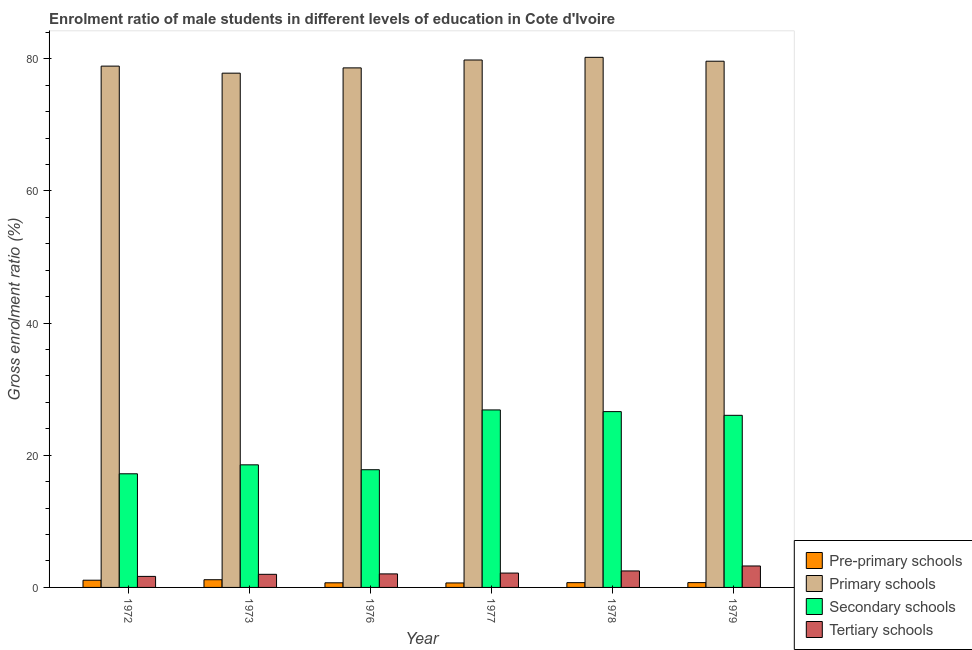How many different coloured bars are there?
Make the answer very short. 4. Are the number of bars per tick equal to the number of legend labels?
Make the answer very short. Yes. How many bars are there on the 6th tick from the left?
Provide a succinct answer. 4. What is the gross enrolment ratio(female) in pre-primary schools in 1976?
Keep it short and to the point. 0.7. Across all years, what is the maximum gross enrolment ratio(female) in tertiary schools?
Offer a very short reply. 3.25. Across all years, what is the minimum gross enrolment ratio(female) in primary schools?
Your response must be concise. 77.82. In which year was the gross enrolment ratio(female) in primary schools maximum?
Your answer should be compact. 1978. In which year was the gross enrolment ratio(female) in secondary schools minimum?
Your response must be concise. 1972. What is the total gross enrolment ratio(female) in secondary schools in the graph?
Offer a very short reply. 133.07. What is the difference between the gross enrolment ratio(female) in pre-primary schools in 1972 and that in 1978?
Give a very brief answer. 0.37. What is the difference between the gross enrolment ratio(female) in secondary schools in 1976 and the gross enrolment ratio(female) in primary schools in 1977?
Offer a terse response. -9.05. What is the average gross enrolment ratio(female) in pre-primary schools per year?
Give a very brief answer. 0.85. In the year 1977, what is the difference between the gross enrolment ratio(female) in tertiary schools and gross enrolment ratio(female) in secondary schools?
Offer a terse response. 0. In how many years, is the gross enrolment ratio(female) in primary schools greater than 28 %?
Provide a succinct answer. 6. What is the ratio of the gross enrolment ratio(female) in primary schools in 1976 to that in 1979?
Provide a succinct answer. 0.99. Is the gross enrolment ratio(female) in primary schools in 1972 less than that in 1977?
Provide a succinct answer. Yes. Is the difference between the gross enrolment ratio(female) in pre-primary schools in 1972 and 1979 greater than the difference between the gross enrolment ratio(female) in secondary schools in 1972 and 1979?
Provide a succinct answer. No. What is the difference between the highest and the second highest gross enrolment ratio(female) in primary schools?
Offer a very short reply. 0.4. What is the difference between the highest and the lowest gross enrolment ratio(female) in pre-primary schools?
Make the answer very short. 0.49. In how many years, is the gross enrolment ratio(female) in pre-primary schools greater than the average gross enrolment ratio(female) in pre-primary schools taken over all years?
Provide a short and direct response. 2. Is the sum of the gross enrolment ratio(female) in secondary schools in 1978 and 1979 greater than the maximum gross enrolment ratio(female) in primary schools across all years?
Make the answer very short. Yes. Is it the case that in every year, the sum of the gross enrolment ratio(female) in primary schools and gross enrolment ratio(female) in secondary schools is greater than the sum of gross enrolment ratio(female) in pre-primary schools and gross enrolment ratio(female) in tertiary schools?
Your response must be concise. Yes. What does the 1st bar from the left in 1972 represents?
Your response must be concise. Pre-primary schools. What does the 4th bar from the right in 1977 represents?
Offer a very short reply. Pre-primary schools. Is it the case that in every year, the sum of the gross enrolment ratio(female) in pre-primary schools and gross enrolment ratio(female) in primary schools is greater than the gross enrolment ratio(female) in secondary schools?
Offer a very short reply. Yes. How many bars are there?
Your answer should be compact. 24. Are all the bars in the graph horizontal?
Your response must be concise. No. How many years are there in the graph?
Offer a terse response. 6. What is the difference between two consecutive major ticks on the Y-axis?
Your answer should be very brief. 20. Are the values on the major ticks of Y-axis written in scientific E-notation?
Provide a succinct answer. No. Does the graph contain any zero values?
Ensure brevity in your answer.  No. Does the graph contain grids?
Make the answer very short. No. Where does the legend appear in the graph?
Provide a succinct answer. Bottom right. How are the legend labels stacked?
Offer a terse response. Vertical. What is the title of the graph?
Offer a very short reply. Enrolment ratio of male students in different levels of education in Cote d'Ivoire. Does "Rule based governance" appear as one of the legend labels in the graph?
Give a very brief answer. No. What is the Gross enrolment ratio (%) in Pre-primary schools in 1972?
Offer a terse response. 1.09. What is the Gross enrolment ratio (%) of Primary schools in 1972?
Provide a short and direct response. 78.89. What is the Gross enrolment ratio (%) in Secondary schools in 1972?
Your answer should be very brief. 17.2. What is the Gross enrolment ratio (%) of Tertiary schools in 1972?
Give a very brief answer. 1.67. What is the Gross enrolment ratio (%) in Pre-primary schools in 1973?
Your answer should be very brief. 1.17. What is the Gross enrolment ratio (%) in Primary schools in 1973?
Give a very brief answer. 77.82. What is the Gross enrolment ratio (%) of Secondary schools in 1973?
Provide a short and direct response. 18.55. What is the Gross enrolment ratio (%) of Tertiary schools in 1973?
Ensure brevity in your answer.  1.98. What is the Gross enrolment ratio (%) in Pre-primary schools in 1976?
Offer a very short reply. 0.7. What is the Gross enrolment ratio (%) of Primary schools in 1976?
Ensure brevity in your answer.  78.62. What is the Gross enrolment ratio (%) of Secondary schools in 1976?
Provide a succinct answer. 17.81. What is the Gross enrolment ratio (%) of Tertiary schools in 1976?
Make the answer very short. 2.05. What is the Gross enrolment ratio (%) in Pre-primary schools in 1977?
Offer a terse response. 0.68. What is the Gross enrolment ratio (%) of Primary schools in 1977?
Give a very brief answer. 79.81. What is the Gross enrolment ratio (%) of Secondary schools in 1977?
Your answer should be very brief. 26.86. What is the Gross enrolment ratio (%) of Tertiary schools in 1977?
Provide a succinct answer. 2.17. What is the Gross enrolment ratio (%) of Pre-primary schools in 1978?
Provide a short and direct response. 0.72. What is the Gross enrolment ratio (%) in Primary schools in 1978?
Your response must be concise. 80.22. What is the Gross enrolment ratio (%) of Secondary schools in 1978?
Provide a succinct answer. 26.61. What is the Gross enrolment ratio (%) of Tertiary schools in 1978?
Your response must be concise. 2.49. What is the Gross enrolment ratio (%) of Pre-primary schools in 1979?
Ensure brevity in your answer.  0.73. What is the Gross enrolment ratio (%) of Primary schools in 1979?
Offer a very short reply. 79.63. What is the Gross enrolment ratio (%) in Secondary schools in 1979?
Your answer should be compact. 26.04. What is the Gross enrolment ratio (%) in Tertiary schools in 1979?
Your answer should be very brief. 3.25. Across all years, what is the maximum Gross enrolment ratio (%) of Pre-primary schools?
Your answer should be very brief. 1.17. Across all years, what is the maximum Gross enrolment ratio (%) of Primary schools?
Your response must be concise. 80.22. Across all years, what is the maximum Gross enrolment ratio (%) in Secondary schools?
Your response must be concise. 26.86. Across all years, what is the maximum Gross enrolment ratio (%) of Tertiary schools?
Provide a succinct answer. 3.25. Across all years, what is the minimum Gross enrolment ratio (%) in Pre-primary schools?
Make the answer very short. 0.68. Across all years, what is the minimum Gross enrolment ratio (%) in Primary schools?
Provide a short and direct response. 77.82. Across all years, what is the minimum Gross enrolment ratio (%) of Secondary schools?
Keep it short and to the point. 17.2. Across all years, what is the minimum Gross enrolment ratio (%) in Tertiary schools?
Offer a very short reply. 1.67. What is the total Gross enrolment ratio (%) of Pre-primary schools in the graph?
Give a very brief answer. 5.08. What is the total Gross enrolment ratio (%) in Primary schools in the graph?
Your answer should be very brief. 474.99. What is the total Gross enrolment ratio (%) in Secondary schools in the graph?
Provide a short and direct response. 133.07. What is the total Gross enrolment ratio (%) in Tertiary schools in the graph?
Provide a short and direct response. 13.61. What is the difference between the Gross enrolment ratio (%) in Pre-primary schools in 1972 and that in 1973?
Provide a succinct answer. -0.07. What is the difference between the Gross enrolment ratio (%) of Primary schools in 1972 and that in 1973?
Offer a very short reply. 1.07. What is the difference between the Gross enrolment ratio (%) of Secondary schools in 1972 and that in 1973?
Offer a very short reply. -1.36. What is the difference between the Gross enrolment ratio (%) in Tertiary schools in 1972 and that in 1973?
Your answer should be very brief. -0.31. What is the difference between the Gross enrolment ratio (%) of Pre-primary schools in 1972 and that in 1976?
Offer a terse response. 0.39. What is the difference between the Gross enrolment ratio (%) of Primary schools in 1972 and that in 1976?
Your answer should be very brief. 0.27. What is the difference between the Gross enrolment ratio (%) in Secondary schools in 1972 and that in 1976?
Provide a short and direct response. -0.62. What is the difference between the Gross enrolment ratio (%) in Tertiary schools in 1972 and that in 1976?
Your answer should be compact. -0.38. What is the difference between the Gross enrolment ratio (%) of Pre-primary schools in 1972 and that in 1977?
Offer a very short reply. 0.41. What is the difference between the Gross enrolment ratio (%) in Primary schools in 1972 and that in 1977?
Your answer should be compact. -0.93. What is the difference between the Gross enrolment ratio (%) in Secondary schools in 1972 and that in 1977?
Offer a terse response. -9.66. What is the difference between the Gross enrolment ratio (%) of Tertiary schools in 1972 and that in 1977?
Offer a terse response. -0.5. What is the difference between the Gross enrolment ratio (%) in Pre-primary schools in 1972 and that in 1978?
Your answer should be compact. 0.37. What is the difference between the Gross enrolment ratio (%) in Primary schools in 1972 and that in 1978?
Offer a terse response. -1.33. What is the difference between the Gross enrolment ratio (%) in Secondary schools in 1972 and that in 1978?
Ensure brevity in your answer.  -9.41. What is the difference between the Gross enrolment ratio (%) of Tertiary schools in 1972 and that in 1978?
Offer a very short reply. -0.83. What is the difference between the Gross enrolment ratio (%) of Pre-primary schools in 1972 and that in 1979?
Your answer should be compact. 0.36. What is the difference between the Gross enrolment ratio (%) in Primary schools in 1972 and that in 1979?
Your answer should be compact. -0.74. What is the difference between the Gross enrolment ratio (%) of Secondary schools in 1972 and that in 1979?
Keep it short and to the point. -8.85. What is the difference between the Gross enrolment ratio (%) of Tertiary schools in 1972 and that in 1979?
Provide a short and direct response. -1.58. What is the difference between the Gross enrolment ratio (%) of Pre-primary schools in 1973 and that in 1976?
Ensure brevity in your answer.  0.47. What is the difference between the Gross enrolment ratio (%) in Primary schools in 1973 and that in 1976?
Your response must be concise. -0.8. What is the difference between the Gross enrolment ratio (%) of Secondary schools in 1973 and that in 1976?
Keep it short and to the point. 0.74. What is the difference between the Gross enrolment ratio (%) in Tertiary schools in 1973 and that in 1976?
Provide a short and direct response. -0.06. What is the difference between the Gross enrolment ratio (%) in Pre-primary schools in 1973 and that in 1977?
Provide a succinct answer. 0.49. What is the difference between the Gross enrolment ratio (%) of Primary schools in 1973 and that in 1977?
Give a very brief answer. -1.99. What is the difference between the Gross enrolment ratio (%) of Secondary schools in 1973 and that in 1977?
Offer a terse response. -8.31. What is the difference between the Gross enrolment ratio (%) in Tertiary schools in 1973 and that in 1977?
Offer a terse response. -0.19. What is the difference between the Gross enrolment ratio (%) of Pre-primary schools in 1973 and that in 1978?
Offer a terse response. 0.44. What is the difference between the Gross enrolment ratio (%) in Primary schools in 1973 and that in 1978?
Provide a succinct answer. -2.4. What is the difference between the Gross enrolment ratio (%) of Secondary schools in 1973 and that in 1978?
Give a very brief answer. -8.05. What is the difference between the Gross enrolment ratio (%) in Tertiary schools in 1973 and that in 1978?
Your response must be concise. -0.51. What is the difference between the Gross enrolment ratio (%) of Pre-primary schools in 1973 and that in 1979?
Give a very brief answer. 0.44. What is the difference between the Gross enrolment ratio (%) in Primary schools in 1973 and that in 1979?
Offer a very short reply. -1.81. What is the difference between the Gross enrolment ratio (%) of Secondary schools in 1973 and that in 1979?
Provide a succinct answer. -7.49. What is the difference between the Gross enrolment ratio (%) in Tertiary schools in 1973 and that in 1979?
Make the answer very short. -1.26. What is the difference between the Gross enrolment ratio (%) in Pre-primary schools in 1976 and that in 1977?
Provide a succinct answer. 0.02. What is the difference between the Gross enrolment ratio (%) of Primary schools in 1976 and that in 1977?
Make the answer very short. -1.19. What is the difference between the Gross enrolment ratio (%) in Secondary schools in 1976 and that in 1977?
Make the answer very short. -9.05. What is the difference between the Gross enrolment ratio (%) of Tertiary schools in 1976 and that in 1977?
Ensure brevity in your answer.  -0.12. What is the difference between the Gross enrolment ratio (%) in Pre-primary schools in 1976 and that in 1978?
Ensure brevity in your answer.  -0.02. What is the difference between the Gross enrolment ratio (%) of Primary schools in 1976 and that in 1978?
Provide a succinct answer. -1.6. What is the difference between the Gross enrolment ratio (%) of Secondary schools in 1976 and that in 1978?
Keep it short and to the point. -8.79. What is the difference between the Gross enrolment ratio (%) of Tertiary schools in 1976 and that in 1978?
Keep it short and to the point. -0.45. What is the difference between the Gross enrolment ratio (%) in Pre-primary schools in 1976 and that in 1979?
Make the answer very short. -0.03. What is the difference between the Gross enrolment ratio (%) in Primary schools in 1976 and that in 1979?
Give a very brief answer. -1.01. What is the difference between the Gross enrolment ratio (%) in Secondary schools in 1976 and that in 1979?
Offer a terse response. -8.23. What is the difference between the Gross enrolment ratio (%) of Tertiary schools in 1976 and that in 1979?
Keep it short and to the point. -1.2. What is the difference between the Gross enrolment ratio (%) in Pre-primary schools in 1977 and that in 1978?
Offer a very short reply. -0.04. What is the difference between the Gross enrolment ratio (%) in Primary schools in 1977 and that in 1978?
Offer a terse response. -0.4. What is the difference between the Gross enrolment ratio (%) of Secondary schools in 1977 and that in 1978?
Make the answer very short. 0.25. What is the difference between the Gross enrolment ratio (%) of Tertiary schools in 1977 and that in 1978?
Your response must be concise. -0.32. What is the difference between the Gross enrolment ratio (%) of Pre-primary schools in 1977 and that in 1979?
Offer a terse response. -0.05. What is the difference between the Gross enrolment ratio (%) in Primary schools in 1977 and that in 1979?
Make the answer very short. 0.18. What is the difference between the Gross enrolment ratio (%) in Secondary schools in 1977 and that in 1979?
Provide a short and direct response. 0.81. What is the difference between the Gross enrolment ratio (%) of Tertiary schools in 1977 and that in 1979?
Ensure brevity in your answer.  -1.07. What is the difference between the Gross enrolment ratio (%) in Pre-primary schools in 1978 and that in 1979?
Your response must be concise. -0.01. What is the difference between the Gross enrolment ratio (%) in Primary schools in 1978 and that in 1979?
Your answer should be compact. 0.59. What is the difference between the Gross enrolment ratio (%) of Secondary schools in 1978 and that in 1979?
Your response must be concise. 0.56. What is the difference between the Gross enrolment ratio (%) of Tertiary schools in 1978 and that in 1979?
Keep it short and to the point. -0.75. What is the difference between the Gross enrolment ratio (%) in Pre-primary schools in 1972 and the Gross enrolment ratio (%) in Primary schools in 1973?
Your answer should be very brief. -76.73. What is the difference between the Gross enrolment ratio (%) in Pre-primary schools in 1972 and the Gross enrolment ratio (%) in Secondary schools in 1973?
Your answer should be very brief. -17.46. What is the difference between the Gross enrolment ratio (%) in Pre-primary schools in 1972 and the Gross enrolment ratio (%) in Tertiary schools in 1973?
Make the answer very short. -0.89. What is the difference between the Gross enrolment ratio (%) in Primary schools in 1972 and the Gross enrolment ratio (%) in Secondary schools in 1973?
Ensure brevity in your answer.  60.34. What is the difference between the Gross enrolment ratio (%) in Primary schools in 1972 and the Gross enrolment ratio (%) in Tertiary schools in 1973?
Ensure brevity in your answer.  76.9. What is the difference between the Gross enrolment ratio (%) in Secondary schools in 1972 and the Gross enrolment ratio (%) in Tertiary schools in 1973?
Your response must be concise. 15.21. What is the difference between the Gross enrolment ratio (%) of Pre-primary schools in 1972 and the Gross enrolment ratio (%) of Primary schools in 1976?
Keep it short and to the point. -77.53. What is the difference between the Gross enrolment ratio (%) of Pre-primary schools in 1972 and the Gross enrolment ratio (%) of Secondary schools in 1976?
Your answer should be very brief. -16.72. What is the difference between the Gross enrolment ratio (%) of Pre-primary schools in 1972 and the Gross enrolment ratio (%) of Tertiary schools in 1976?
Ensure brevity in your answer.  -0.95. What is the difference between the Gross enrolment ratio (%) in Primary schools in 1972 and the Gross enrolment ratio (%) in Secondary schools in 1976?
Provide a short and direct response. 61.07. What is the difference between the Gross enrolment ratio (%) of Primary schools in 1972 and the Gross enrolment ratio (%) of Tertiary schools in 1976?
Offer a very short reply. 76.84. What is the difference between the Gross enrolment ratio (%) of Secondary schools in 1972 and the Gross enrolment ratio (%) of Tertiary schools in 1976?
Offer a very short reply. 15.15. What is the difference between the Gross enrolment ratio (%) in Pre-primary schools in 1972 and the Gross enrolment ratio (%) in Primary schools in 1977?
Provide a succinct answer. -78.72. What is the difference between the Gross enrolment ratio (%) of Pre-primary schools in 1972 and the Gross enrolment ratio (%) of Secondary schools in 1977?
Provide a short and direct response. -25.77. What is the difference between the Gross enrolment ratio (%) in Pre-primary schools in 1972 and the Gross enrolment ratio (%) in Tertiary schools in 1977?
Offer a very short reply. -1.08. What is the difference between the Gross enrolment ratio (%) of Primary schools in 1972 and the Gross enrolment ratio (%) of Secondary schools in 1977?
Offer a terse response. 52.03. What is the difference between the Gross enrolment ratio (%) in Primary schools in 1972 and the Gross enrolment ratio (%) in Tertiary schools in 1977?
Make the answer very short. 76.71. What is the difference between the Gross enrolment ratio (%) of Secondary schools in 1972 and the Gross enrolment ratio (%) of Tertiary schools in 1977?
Keep it short and to the point. 15.02. What is the difference between the Gross enrolment ratio (%) in Pre-primary schools in 1972 and the Gross enrolment ratio (%) in Primary schools in 1978?
Your answer should be compact. -79.12. What is the difference between the Gross enrolment ratio (%) in Pre-primary schools in 1972 and the Gross enrolment ratio (%) in Secondary schools in 1978?
Give a very brief answer. -25.51. What is the difference between the Gross enrolment ratio (%) in Pre-primary schools in 1972 and the Gross enrolment ratio (%) in Tertiary schools in 1978?
Your answer should be compact. -1.4. What is the difference between the Gross enrolment ratio (%) in Primary schools in 1972 and the Gross enrolment ratio (%) in Secondary schools in 1978?
Keep it short and to the point. 52.28. What is the difference between the Gross enrolment ratio (%) of Primary schools in 1972 and the Gross enrolment ratio (%) of Tertiary schools in 1978?
Give a very brief answer. 76.39. What is the difference between the Gross enrolment ratio (%) of Secondary schools in 1972 and the Gross enrolment ratio (%) of Tertiary schools in 1978?
Offer a terse response. 14.7. What is the difference between the Gross enrolment ratio (%) of Pre-primary schools in 1972 and the Gross enrolment ratio (%) of Primary schools in 1979?
Your answer should be very brief. -78.54. What is the difference between the Gross enrolment ratio (%) of Pre-primary schools in 1972 and the Gross enrolment ratio (%) of Secondary schools in 1979?
Your answer should be very brief. -24.95. What is the difference between the Gross enrolment ratio (%) in Pre-primary schools in 1972 and the Gross enrolment ratio (%) in Tertiary schools in 1979?
Your response must be concise. -2.15. What is the difference between the Gross enrolment ratio (%) in Primary schools in 1972 and the Gross enrolment ratio (%) in Secondary schools in 1979?
Your answer should be compact. 52.84. What is the difference between the Gross enrolment ratio (%) in Primary schools in 1972 and the Gross enrolment ratio (%) in Tertiary schools in 1979?
Your answer should be very brief. 75.64. What is the difference between the Gross enrolment ratio (%) in Secondary schools in 1972 and the Gross enrolment ratio (%) in Tertiary schools in 1979?
Provide a succinct answer. 13.95. What is the difference between the Gross enrolment ratio (%) in Pre-primary schools in 1973 and the Gross enrolment ratio (%) in Primary schools in 1976?
Offer a terse response. -77.46. What is the difference between the Gross enrolment ratio (%) in Pre-primary schools in 1973 and the Gross enrolment ratio (%) in Secondary schools in 1976?
Make the answer very short. -16.65. What is the difference between the Gross enrolment ratio (%) in Pre-primary schools in 1973 and the Gross enrolment ratio (%) in Tertiary schools in 1976?
Offer a very short reply. -0.88. What is the difference between the Gross enrolment ratio (%) of Primary schools in 1973 and the Gross enrolment ratio (%) of Secondary schools in 1976?
Your answer should be very brief. 60.01. What is the difference between the Gross enrolment ratio (%) in Primary schools in 1973 and the Gross enrolment ratio (%) in Tertiary schools in 1976?
Provide a succinct answer. 75.77. What is the difference between the Gross enrolment ratio (%) of Secondary schools in 1973 and the Gross enrolment ratio (%) of Tertiary schools in 1976?
Provide a succinct answer. 16.5. What is the difference between the Gross enrolment ratio (%) in Pre-primary schools in 1973 and the Gross enrolment ratio (%) in Primary schools in 1977?
Provide a succinct answer. -78.65. What is the difference between the Gross enrolment ratio (%) in Pre-primary schools in 1973 and the Gross enrolment ratio (%) in Secondary schools in 1977?
Your response must be concise. -25.69. What is the difference between the Gross enrolment ratio (%) of Pre-primary schools in 1973 and the Gross enrolment ratio (%) of Tertiary schools in 1977?
Give a very brief answer. -1.01. What is the difference between the Gross enrolment ratio (%) in Primary schools in 1973 and the Gross enrolment ratio (%) in Secondary schools in 1977?
Your answer should be very brief. 50.96. What is the difference between the Gross enrolment ratio (%) in Primary schools in 1973 and the Gross enrolment ratio (%) in Tertiary schools in 1977?
Ensure brevity in your answer.  75.65. What is the difference between the Gross enrolment ratio (%) of Secondary schools in 1973 and the Gross enrolment ratio (%) of Tertiary schools in 1977?
Give a very brief answer. 16.38. What is the difference between the Gross enrolment ratio (%) of Pre-primary schools in 1973 and the Gross enrolment ratio (%) of Primary schools in 1978?
Offer a terse response. -79.05. What is the difference between the Gross enrolment ratio (%) in Pre-primary schools in 1973 and the Gross enrolment ratio (%) in Secondary schools in 1978?
Give a very brief answer. -25.44. What is the difference between the Gross enrolment ratio (%) of Pre-primary schools in 1973 and the Gross enrolment ratio (%) of Tertiary schools in 1978?
Ensure brevity in your answer.  -1.33. What is the difference between the Gross enrolment ratio (%) in Primary schools in 1973 and the Gross enrolment ratio (%) in Secondary schools in 1978?
Provide a succinct answer. 51.22. What is the difference between the Gross enrolment ratio (%) in Primary schools in 1973 and the Gross enrolment ratio (%) in Tertiary schools in 1978?
Provide a succinct answer. 75.33. What is the difference between the Gross enrolment ratio (%) of Secondary schools in 1973 and the Gross enrolment ratio (%) of Tertiary schools in 1978?
Give a very brief answer. 16.06. What is the difference between the Gross enrolment ratio (%) of Pre-primary schools in 1973 and the Gross enrolment ratio (%) of Primary schools in 1979?
Offer a terse response. -78.46. What is the difference between the Gross enrolment ratio (%) in Pre-primary schools in 1973 and the Gross enrolment ratio (%) in Secondary schools in 1979?
Ensure brevity in your answer.  -24.88. What is the difference between the Gross enrolment ratio (%) in Pre-primary schools in 1973 and the Gross enrolment ratio (%) in Tertiary schools in 1979?
Your response must be concise. -2.08. What is the difference between the Gross enrolment ratio (%) of Primary schools in 1973 and the Gross enrolment ratio (%) of Secondary schools in 1979?
Give a very brief answer. 51.78. What is the difference between the Gross enrolment ratio (%) in Primary schools in 1973 and the Gross enrolment ratio (%) in Tertiary schools in 1979?
Offer a terse response. 74.58. What is the difference between the Gross enrolment ratio (%) of Secondary schools in 1973 and the Gross enrolment ratio (%) of Tertiary schools in 1979?
Offer a very short reply. 15.31. What is the difference between the Gross enrolment ratio (%) of Pre-primary schools in 1976 and the Gross enrolment ratio (%) of Primary schools in 1977?
Provide a succinct answer. -79.11. What is the difference between the Gross enrolment ratio (%) of Pre-primary schools in 1976 and the Gross enrolment ratio (%) of Secondary schools in 1977?
Your answer should be compact. -26.16. What is the difference between the Gross enrolment ratio (%) in Pre-primary schools in 1976 and the Gross enrolment ratio (%) in Tertiary schools in 1977?
Give a very brief answer. -1.47. What is the difference between the Gross enrolment ratio (%) in Primary schools in 1976 and the Gross enrolment ratio (%) in Secondary schools in 1977?
Provide a succinct answer. 51.76. What is the difference between the Gross enrolment ratio (%) in Primary schools in 1976 and the Gross enrolment ratio (%) in Tertiary schools in 1977?
Your answer should be very brief. 76.45. What is the difference between the Gross enrolment ratio (%) in Secondary schools in 1976 and the Gross enrolment ratio (%) in Tertiary schools in 1977?
Your answer should be compact. 15.64. What is the difference between the Gross enrolment ratio (%) of Pre-primary schools in 1976 and the Gross enrolment ratio (%) of Primary schools in 1978?
Make the answer very short. -79.52. What is the difference between the Gross enrolment ratio (%) in Pre-primary schools in 1976 and the Gross enrolment ratio (%) in Secondary schools in 1978?
Provide a short and direct response. -25.91. What is the difference between the Gross enrolment ratio (%) in Pre-primary schools in 1976 and the Gross enrolment ratio (%) in Tertiary schools in 1978?
Provide a short and direct response. -1.8. What is the difference between the Gross enrolment ratio (%) in Primary schools in 1976 and the Gross enrolment ratio (%) in Secondary schools in 1978?
Provide a short and direct response. 52.02. What is the difference between the Gross enrolment ratio (%) in Primary schools in 1976 and the Gross enrolment ratio (%) in Tertiary schools in 1978?
Offer a terse response. 76.13. What is the difference between the Gross enrolment ratio (%) of Secondary schools in 1976 and the Gross enrolment ratio (%) of Tertiary schools in 1978?
Your response must be concise. 15.32. What is the difference between the Gross enrolment ratio (%) of Pre-primary schools in 1976 and the Gross enrolment ratio (%) of Primary schools in 1979?
Provide a succinct answer. -78.93. What is the difference between the Gross enrolment ratio (%) in Pre-primary schools in 1976 and the Gross enrolment ratio (%) in Secondary schools in 1979?
Give a very brief answer. -25.34. What is the difference between the Gross enrolment ratio (%) in Pre-primary schools in 1976 and the Gross enrolment ratio (%) in Tertiary schools in 1979?
Your answer should be compact. -2.55. What is the difference between the Gross enrolment ratio (%) of Primary schools in 1976 and the Gross enrolment ratio (%) of Secondary schools in 1979?
Offer a terse response. 52.58. What is the difference between the Gross enrolment ratio (%) of Primary schools in 1976 and the Gross enrolment ratio (%) of Tertiary schools in 1979?
Give a very brief answer. 75.38. What is the difference between the Gross enrolment ratio (%) of Secondary schools in 1976 and the Gross enrolment ratio (%) of Tertiary schools in 1979?
Your response must be concise. 14.57. What is the difference between the Gross enrolment ratio (%) in Pre-primary schools in 1977 and the Gross enrolment ratio (%) in Primary schools in 1978?
Your answer should be very brief. -79.54. What is the difference between the Gross enrolment ratio (%) in Pre-primary schools in 1977 and the Gross enrolment ratio (%) in Secondary schools in 1978?
Your answer should be compact. -25.93. What is the difference between the Gross enrolment ratio (%) in Pre-primary schools in 1977 and the Gross enrolment ratio (%) in Tertiary schools in 1978?
Ensure brevity in your answer.  -1.82. What is the difference between the Gross enrolment ratio (%) of Primary schools in 1977 and the Gross enrolment ratio (%) of Secondary schools in 1978?
Provide a succinct answer. 53.21. What is the difference between the Gross enrolment ratio (%) in Primary schools in 1977 and the Gross enrolment ratio (%) in Tertiary schools in 1978?
Provide a succinct answer. 77.32. What is the difference between the Gross enrolment ratio (%) in Secondary schools in 1977 and the Gross enrolment ratio (%) in Tertiary schools in 1978?
Provide a succinct answer. 24.36. What is the difference between the Gross enrolment ratio (%) in Pre-primary schools in 1977 and the Gross enrolment ratio (%) in Primary schools in 1979?
Keep it short and to the point. -78.95. What is the difference between the Gross enrolment ratio (%) of Pre-primary schools in 1977 and the Gross enrolment ratio (%) of Secondary schools in 1979?
Ensure brevity in your answer.  -25.37. What is the difference between the Gross enrolment ratio (%) of Pre-primary schools in 1977 and the Gross enrolment ratio (%) of Tertiary schools in 1979?
Give a very brief answer. -2.57. What is the difference between the Gross enrolment ratio (%) of Primary schools in 1977 and the Gross enrolment ratio (%) of Secondary schools in 1979?
Your answer should be very brief. 53.77. What is the difference between the Gross enrolment ratio (%) in Primary schools in 1977 and the Gross enrolment ratio (%) in Tertiary schools in 1979?
Make the answer very short. 76.57. What is the difference between the Gross enrolment ratio (%) of Secondary schools in 1977 and the Gross enrolment ratio (%) of Tertiary schools in 1979?
Provide a succinct answer. 23.61. What is the difference between the Gross enrolment ratio (%) of Pre-primary schools in 1978 and the Gross enrolment ratio (%) of Primary schools in 1979?
Your response must be concise. -78.91. What is the difference between the Gross enrolment ratio (%) of Pre-primary schools in 1978 and the Gross enrolment ratio (%) of Secondary schools in 1979?
Offer a very short reply. -25.32. What is the difference between the Gross enrolment ratio (%) in Pre-primary schools in 1978 and the Gross enrolment ratio (%) in Tertiary schools in 1979?
Offer a terse response. -2.52. What is the difference between the Gross enrolment ratio (%) of Primary schools in 1978 and the Gross enrolment ratio (%) of Secondary schools in 1979?
Offer a very short reply. 54.17. What is the difference between the Gross enrolment ratio (%) of Primary schools in 1978 and the Gross enrolment ratio (%) of Tertiary schools in 1979?
Offer a terse response. 76.97. What is the difference between the Gross enrolment ratio (%) of Secondary schools in 1978 and the Gross enrolment ratio (%) of Tertiary schools in 1979?
Your answer should be compact. 23.36. What is the average Gross enrolment ratio (%) of Pre-primary schools per year?
Your response must be concise. 0.85. What is the average Gross enrolment ratio (%) of Primary schools per year?
Keep it short and to the point. 79.16. What is the average Gross enrolment ratio (%) of Secondary schools per year?
Make the answer very short. 22.18. What is the average Gross enrolment ratio (%) of Tertiary schools per year?
Give a very brief answer. 2.27. In the year 1972, what is the difference between the Gross enrolment ratio (%) in Pre-primary schools and Gross enrolment ratio (%) in Primary schools?
Offer a terse response. -77.79. In the year 1972, what is the difference between the Gross enrolment ratio (%) of Pre-primary schools and Gross enrolment ratio (%) of Secondary schools?
Offer a very short reply. -16.1. In the year 1972, what is the difference between the Gross enrolment ratio (%) in Pre-primary schools and Gross enrolment ratio (%) in Tertiary schools?
Your answer should be very brief. -0.58. In the year 1972, what is the difference between the Gross enrolment ratio (%) in Primary schools and Gross enrolment ratio (%) in Secondary schools?
Keep it short and to the point. 61.69. In the year 1972, what is the difference between the Gross enrolment ratio (%) in Primary schools and Gross enrolment ratio (%) in Tertiary schools?
Keep it short and to the point. 77.22. In the year 1972, what is the difference between the Gross enrolment ratio (%) of Secondary schools and Gross enrolment ratio (%) of Tertiary schools?
Your answer should be compact. 15.53. In the year 1973, what is the difference between the Gross enrolment ratio (%) in Pre-primary schools and Gross enrolment ratio (%) in Primary schools?
Your answer should be very brief. -76.66. In the year 1973, what is the difference between the Gross enrolment ratio (%) in Pre-primary schools and Gross enrolment ratio (%) in Secondary schools?
Offer a very short reply. -17.39. In the year 1973, what is the difference between the Gross enrolment ratio (%) in Pre-primary schools and Gross enrolment ratio (%) in Tertiary schools?
Provide a short and direct response. -0.82. In the year 1973, what is the difference between the Gross enrolment ratio (%) of Primary schools and Gross enrolment ratio (%) of Secondary schools?
Your answer should be very brief. 59.27. In the year 1973, what is the difference between the Gross enrolment ratio (%) in Primary schools and Gross enrolment ratio (%) in Tertiary schools?
Your answer should be very brief. 75.84. In the year 1973, what is the difference between the Gross enrolment ratio (%) in Secondary schools and Gross enrolment ratio (%) in Tertiary schools?
Ensure brevity in your answer.  16.57. In the year 1976, what is the difference between the Gross enrolment ratio (%) of Pre-primary schools and Gross enrolment ratio (%) of Primary schools?
Your answer should be very brief. -77.92. In the year 1976, what is the difference between the Gross enrolment ratio (%) in Pre-primary schools and Gross enrolment ratio (%) in Secondary schools?
Offer a very short reply. -17.11. In the year 1976, what is the difference between the Gross enrolment ratio (%) of Pre-primary schools and Gross enrolment ratio (%) of Tertiary schools?
Offer a very short reply. -1.35. In the year 1976, what is the difference between the Gross enrolment ratio (%) in Primary schools and Gross enrolment ratio (%) in Secondary schools?
Make the answer very short. 60.81. In the year 1976, what is the difference between the Gross enrolment ratio (%) of Primary schools and Gross enrolment ratio (%) of Tertiary schools?
Provide a short and direct response. 76.57. In the year 1976, what is the difference between the Gross enrolment ratio (%) of Secondary schools and Gross enrolment ratio (%) of Tertiary schools?
Give a very brief answer. 15.76. In the year 1977, what is the difference between the Gross enrolment ratio (%) of Pre-primary schools and Gross enrolment ratio (%) of Primary schools?
Your answer should be compact. -79.13. In the year 1977, what is the difference between the Gross enrolment ratio (%) in Pre-primary schools and Gross enrolment ratio (%) in Secondary schools?
Your answer should be compact. -26.18. In the year 1977, what is the difference between the Gross enrolment ratio (%) of Pre-primary schools and Gross enrolment ratio (%) of Tertiary schools?
Keep it short and to the point. -1.49. In the year 1977, what is the difference between the Gross enrolment ratio (%) of Primary schools and Gross enrolment ratio (%) of Secondary schools?
Your answer should be compact. 52.95. In the year 1977, what is the difference between the Gross enrolment ratio (%) of Primary schools and Gross enrolment ratio (%) of Tertiary schools?
Offer a terse response. 77.64. In the year 1977, what is the difference between the Gross enrolment ratio (%) of Secondary schools and Gross enrolment ratio (%) of Tertiary schools?
Make the answer very short. 24.69. In the year 1978, what is the difference between the Gross enrolment ratio (%) of Pre-primary schools and Gross enrolment ratio (%) of Primary schools?
Your answer should be very brief. -79.49. In the year 1978, what is the difference between the Gross enrolment ratio (%) in Pre-primary schools and Gross enrolment ratio (%) in Secondary schools?
Your answer should be compact. -25.88. In the year 1978, what is the difference between the Gross enrolment ratio (%) in Pre-primary schools and Gross enrolment ratio (%) in Tertiary schools?
Provide a short and direct response. -1.77. In the year 1978, what is the difference between the Gross enrolment ratio (%) in Primary schools and Gross enrolment ratio (%) in Secondary schools?
Give a very brief answer. 53.61. In the year 1978, what is the difference between the Gross enrolment ratio (%) in Primary schools and Gross enrolment ratio (%) in Tertiary schools?
Offer a terse response. 77.72. In the year 1978, what is the difference between the Gross enrolment ratio (%) of Secondary schools and Gross enrolment ratio (%) of Tertiary schools?
Ensure brevity in your answer.  24.11. In the year 1979, what is the difference between the Gross enrolment ratio (%) of Pre-primary schools and Gross enrolment ratio (%) of Primary schools?
Provide a short and direct response. -78.9. In the year 1979, what is the difference between the Gross enrolment ratio (%) of Pre-primary schools and Gross enrolment ratio (%) of Secondary schools?
Your answer should be compact. -25.32. In the year 1979, what is the difference between the Gross enrolment ratio (%) in Pre-primary schools and Gross enrolment ratio (%) in Tertiary schools?
Give a very brief answer. -2.52. In the year 1979, what is the difference between the Gross enrolment ratio (%) in Primary schools and Gross enrolment ratio (%) in Secondary schools?
Your answer should be compact. 53.58. In the year 1979, what is the difference between the Gross enrolment ratio (%) in Primary schools and Gross enrolment ratio (%) in Tertiary schools?
Your answer should be very brief. 76.38. In the year 1979, what is the difference between the Gross enrolment ratio (%) in Secondary schools and Gross enrolment ratio (%) in Tertiary schools?
Your answer should be compact. 22.8. What is the ratio of the Gross enrolment ratio (%) of Pre-primary schools in 1972 to that in 1973?
Offer a very short reply. 0.94. What is the ratio of the Gross enrolment ratio (%) of Primary schools in 1972 to that in 1973?
Provide a succinct answer. 1.01. What is the ratio of the Gross enrolment ratio (%) in Secondary schools in 1972 to that in 1973?
Provide a succinct answer. 0.93. What is the ratio of the Gross enrolment ratio (%) of Tertiary schools in 1972 to that in 1973?
Offer a terse response. 0.84. What is the ratio of the Gross enrolment ratio (%) of Pre-primary schools in 1972 to that in 1976?
Give a very brief answer. 1.56. What is the ratio of the Gross enrolment ratio (%) in Primary schools in 1972 to that in 1976?
Your response must be concise. 1. What is the ratio of the Gross enrolment ratio (%) of Secondary schools in 1972 to that in 1976?
Keep it short and to the point. 0.97. What is the ratio of the Gross enrolment ratio (%) in Tertiary schools in 1972 to that in 1976?
Provide a short and direct response. 0.82. What is the ratio of the Gross enrolment ratio (%) of Pre-primary schools in 1972 to that in 1977?
Provide a short and direct response. 1.61. What is the ratio of the Gross enrolment ratio (%) in Primary schools in 1972 to that in 1977?
Make the answer very short. 0.99. What is the ratio of the Gross enrolment ratio (%) in Secondary schools in 1972 to that in 1977?
Provide a short and direct response. 0.64. What is the ratio of the Gross enrolment ratio (%) of Tertiary schools in 1972 to that in 1977?
Offer a very short reply. 0.77. What is the ratio of the Gross enrolment ratio (%) of Pre-primary schools in 1972 to that in 1978?
Your answer should be very brief. 1.51. What is the ratio of the Gross enrolment ratio (%) of Primary schools in 1972 to that in 1978?
Ensure brevity in your answer.  0.98. What is the ratio of the Gross enrolment ratio (%) in Secondary schools in 1972 to that in 1978?
Offer a very short reply. 0.65. What is the ratio of the Gross enrolment ratio (%) in Tertiary schools in 1972 to that in 1978?
Give a very brief answer. 0.67. What is the ratio of the Gross enrolment ratio (%) in Pre-primary schools in 1972 to that in 1979?
Offer a terse response. 1.5. What is the ratio of the Gross enrolment ratio (%) of Secondary schools in 1972 to that in 1979?
Give a very brief answer. 0.66. What is the ratio of the Gross enrolment ratio (%) in Tertiary schools in 1972 to that in 1979?
Ensure brevity in your answer.  0.51. What is the ratio of the Gross enrolment ratio (%) in Pre-primary schools in 1973 to that in 1976?
Provide a succinct answer. 1.67. What is the ratio of the Gross enrolment ratio (%) in Secondary schools in 1973 to that in 1976?
Ensure brevity in your answer.  1.04. What is the ratio of the Gross enrolment ratio (%) of Tertiary schools in 1973 to that in 1976?
Ensure brevity in your answer.  0.97. What is the ratio of the Gross enrolment ratio (%) in Pre-primary schools in 1973 to that in 1977?
Ensure brevity in your answer.  1.72. What is the ratio of the Gross enrolment ratio (%) in Primary schools in 1973 to that in 1977?
Your answer should be very brief. 0.98. What is the ratio of the Gross enrolment ratio (%) in Secondary schools in 1973 to that in 1977?
Make the answer very short. 0.69. What is the ratio of the Gross enrolment ratio (%) of Tertiary schools in 1973 to that in 1977?
Your response must be concise. 0.91. What is the ratio of the Gross enrolment ratio (%) in Pre-primary schools in 1973 to that in 1978?
Offer a very short reply. 1.61. What is the ratio of the Gross enrolment ratio (%) in Primary schools in 1973 to that in 1978?
Keep it short and to the point. 0.97. What is the ratio of the Gross enrolment ratio (%) of Secondary schools in 1973 to that in 1978?
Keep it short and to the point. 0.7. What is the ratio of the Gross enrolment ratio (%) of Tertiary schools in 1973 to that in 1978?
Provide a short and direct response. 0.79. What is the ratio of the Gross enrolment ratio (%) of Pre-primary schools in 1973 to that in 1979?
Provide a succinct answer. 1.6. What is the ratio of the Gross enrolment ratio (%) in Primary schools in 1973 to that in 1979?
Your answer should be very brief. 0.98. What is the ratio of the Gross enrolment ratio (%) of Secondary schools in 1973 to that in 1979?
Offer a terse response. 0.71. What is the ratio of the Gross enrolment ratio (%) of Tertiary schools in 1973 to that in 1979?
Your response must be concise. 0.61. What is the ratio of the Gross enrolment ratio (%) of Pre-primary schools in 1976 to that in 1977?
Offer a very short reply. 1.03. What is the ratio of the Gross enrolment ratio (%) of Primary schools in 1976 to that in 1977?
Provide a short and direct response. 0.99. What is the ratio of the Gross enrolment ratio (%) of Secondary schools in 1976 to that in 1977?
Make the answer very short. 0.66. What is the ratio of the Gross enrolment ratio (%) of Tertiary schools in 1976 to that in 1977?
Your answer should be compact. 0.94. What is the ratio of the Gross enrolment ratio (%) of Pre-primary schools in 1976 to that in 1978?
Offer a terse response. 0.97. What is the ratio of the Gross enrolment ratio (%) in Primary schools in 1976 to that in 1978?
Your answer should be very brief. 0.98. What is the ratio of the Gross enrolment ratio (%) of Secondary schools in 1976 to that in 1978?
Offer a very short reply. 0.67. What is the ratio of the Gross enrolment ratio (%) in Tertiary schools in 1976 to that in 1978?
Make the answer very short. 0.82. What is the ratio of the Gross enrolment ratio (%) in Pre-primary schools in 1976 to that in 1979?
Make the answer very short. 0.96. What is the ratio of the Gross enrolment ratio (%) in Primary schools in 1976 to that in 1979?
Give a very brief answer. 0.99. What is the ratio of the Gross enrolment ratio (%) of Secondary schools in 1976 to that in 1979?
Keep it short and to the point. 0.68. What is the ratio of the Gross enrolment ratio (%) in Tertiary schools in 1976 to that in 1979?
Give a very brief answer. 0.63. What is the ratio of the Gross enrolment ratio (%) in Pre-primary schools in 1977 to that in 1978?
Provide a succinct answer. 0.94. What is the ratio of the Gross enrolment ratio (%) of Primary schools in 1977 to that in 1978?
Your response must be concise. 0.99. What is the ratio of the Gross enrolment ratio (%) of Secondary schools in 1977 to that in 1978?
Provide a succinct answer. 1.01. What is the ratio of the Gross enrolment ratio (%) in Tertiary schools in 1977 to that in 1978?
Ensure brevity in your answer.  0.87. What is the ratio of the Gross enrolment ratio (%) of Pre-primary schools in 1977 to that in 1979?
Give a very brief answer. 0.93. What is the ratio of the Gross enrolment ratio (%) of Primary schools in 1977 to that in 1979?
Give a very brief answer. 1. What is the ratio of the Gross enrolment ratio (%) in Secondary schools in 1977 to that in 1979?
Your response must be concise. 1.03. What is the ratio of the Gross enrolment ratio (%) of Tertiary schools in 1977 to that in 1979?
Make the answer very short. 0.67. What is the ratio of the Gross enrolment ratio (%) in Primary schools in 1978 to that in 1979?
Provide a short and direct response. 1.01. What is the ratio of the Gross enrolment ratio (%) of Secondary schools in 1978 to that in 1979?
Offer a very short reply. 1.02. What is the ratio of the Gross enrolment ratio (%) in Tertiary schools in 1978 to that in 1979?
Offer a very short reply. 0.77. What is the difference between the highest and the second highest Gross enrolment ratio (%) in Pre-primary schools?
Give a very brief answer. 0.07. What is the difference between the highest and the second highest Gross enrolment ratio (%) in Primary schools?
Keep it short and to the point. 0.4. What is the difference between the highest and the second highest Gross enrolment ratio (%) in Secondary schools?
Give a very brief answer. 0.25. What is the difference between the highest and the second highest Gross enrolment ratio (%) of Tertiary schools?
Make the answer very short. 0.75. What is the difference between the highest and the lowest Gross enrolment ratio (%) of Pre-primary schools?
Offer a very short reply. 0.49. What is the difference between the highest and the lowest Gross enrolment ratio (%) in Primary schools?
Your answer should be very brief. 2.4. What is the difference between the highest and the lowest Gross enrolment ratio (%) in Secondary schools?
Provide a short and direct response. 9.66. What is the difference between the highest and the lowest Gross enrolment ratio (%) of Tertiary schools?
Offer a very short reply. 1.58. 